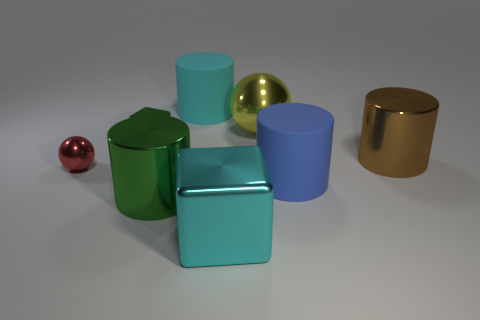Is the large cyan object that is in front of the small red metallic sphere made of the same material as the large cyan object that is behind the big cyan shiny block?
Keep it short and to the point. No. Is the number of big brown things less than the number of cylinders?
Make the answer very short. Yes. Are there any big cyan rubber objects on the left side of the brown thing?
Keep it short and to the point. Yes. Is the material of the small red object the same as the large yellow object?
Offer a terse response. Yes. There is another big metallic thing that is the same shape as the brown object; what color is it?
Your response must be concise. Green. There is a cylinder behind the green shiny cube; does it have the same color as the large metallic cube?
Give a very brief answer. Yes. What number of purple objects are the same material as the tiny green thing?
Offer a terse response. 0. There is a tiny green metal object; how many yellow balls are left of it?
Give a very brief answer. 0. How big is the brown cylinder?
Keep it short and to the point. Large. What color is the metallic cylinder that is the same size as the brown object?
Provide a succinct answer. Green. 